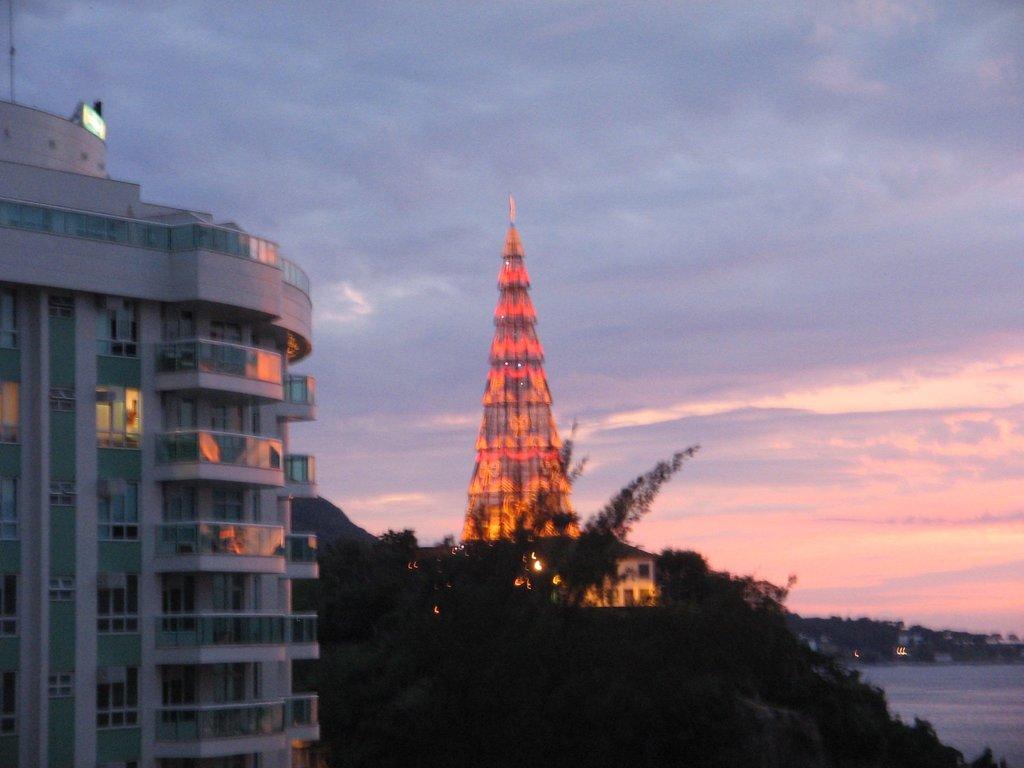Describe this image in one or two sentences. In this image in the front there is a building. In the center there are trees. In the background there is a tower and there are trees, there is water and the sky is cloudy. 